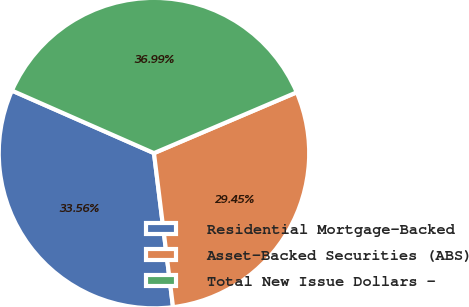Convert chart to OTSL. <chart><loc_0><loc_0><loc_500><loc_500><pie_chart><fcel>Residential Mortgage-Backed<fcel>Asset-Backed Securities (ABS)<fcel>Total New Issue Dollars -<nl><fcel>33.56%<fcel>29.45%<fcel>36.99%<nl></chart> 